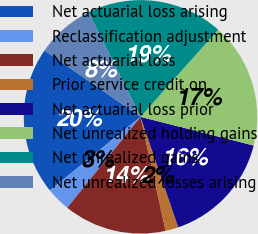Convert chart. <chart><loc_0><loc_0><loc_500><loc_500><pie_chart><fcel>Net actuarial loss arising<fcel>Reclassification adjustment<fcel>Net actuarial loss<fcel>Prior service credit on<fcel>Net actuarial loss prior<fcel>Net unrealized holding gains<fcel>Net unrealized gains<fcel>Net unrealized losses arising<nl><fcel>20.48%<fcel>3.35%<fcel>14.25%<fcel>1.79%<fcel>15.81%<fcel>17.37%<fcel>18.93%<fcel>8.02%<nl></chart> 